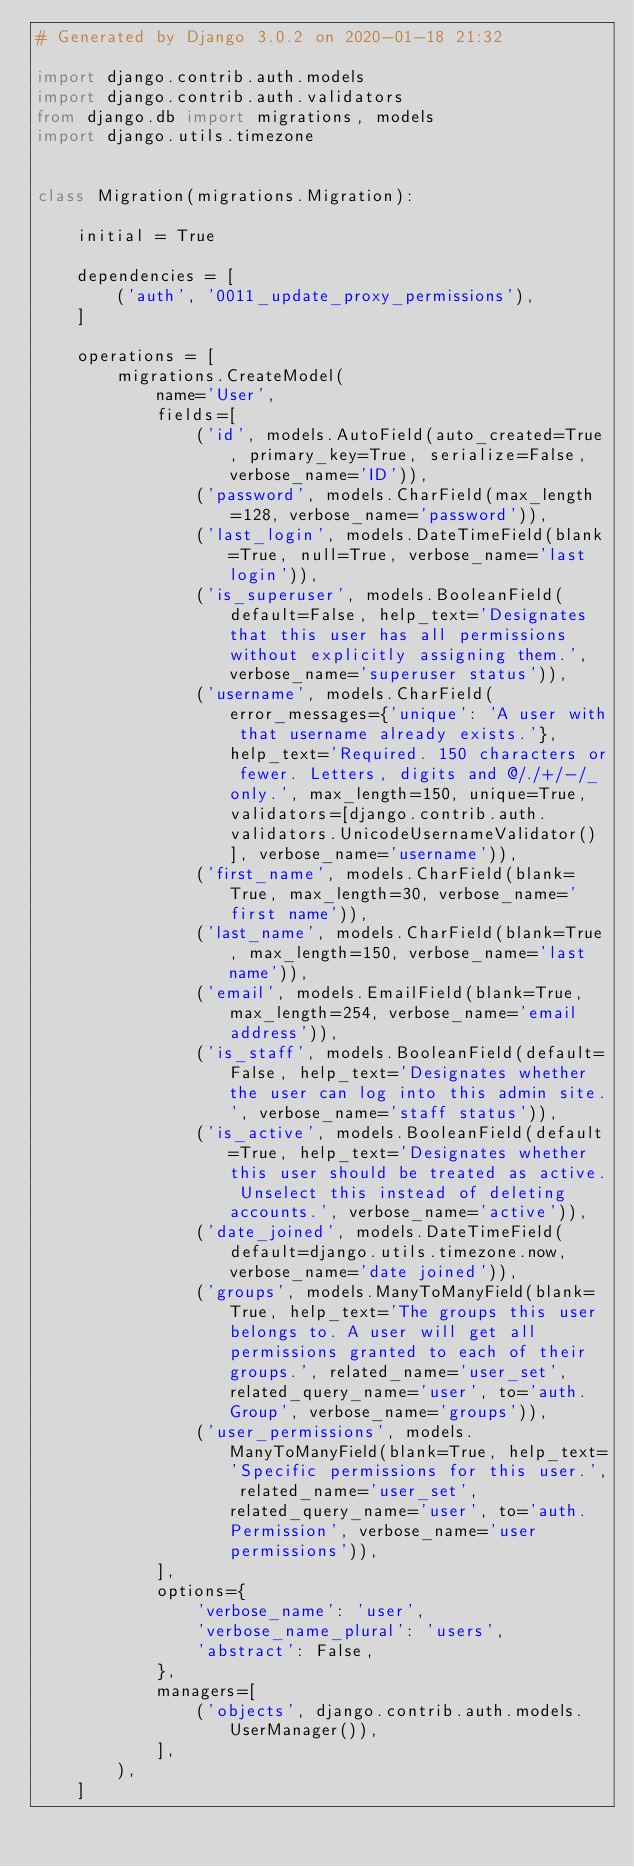<code> <loc_0><loc_0><loc_500><loc_500><_Python_># Generated by Django 3.0.2 on 2020-01-18 21:32

import django.contrib.auth.models
import django.contrib.auth.validators
from django.db import migrations, models
import django.utils.timezone


class Migration(migrations.Migration):

    initial = True

    dependencies = [
        ('auth', '0011_update_proxy_permissions'),
    ]

    operations = [
        migrations.CreateModel(
            name='User',
            fields=[
                ('id', models.AutoField(auto_created=True, primary_key=True, serialize=False, verbose_name='ID')),
                ('password', models.CharField(max_length=128, verbose_name='password')),
                ('last_login', models.DateTimeField(blank=True, null=True, verbose_name='last login')),
                ('is_superuser', models.BooleanField(default=False, help_text='Designates that this user has all permissions without explicitly assigning them.', verbose_name='superuser status')),
                ('username', models.CharField(error_messages={'unique': 'A user with that username already exists.'}, help_text='Required. 150 characters or fewer. Letters, digits and @/./+/-/_ only.', max_length=150, unique=True, validators=[django.contrib.auth.validators.UnicodeUsernameValidator()], verbose_name='username')),
                ('first_name', models.CharField(blank=True, max_length=30, verbose_name='first name')),
                ('last_name', models.CharField(blank=True, max_length=150, verbose_name='last name')),
                ('email', models.EmailField(blank=True, max_length=254, verbose_name='email address')),
                ('is_staff', models.BooleanField(default=False, help_text='Designates whether the user can log into this admin site.', verbose_name='staff status')),
                ('is_active', models.BooleanField(default=True, help_text='Designates whether this user should be treated as active. Unselect this instead of deleting accounts.', verbose_name='active')),
                ('date_joined', models.DateTimeField(default=django.utils.timezone.now, verbose_name='date joined')),
                ('groups', models.ManyToManyField(blank=True, help_text='The groups this user belongs to. A user will get all permissions granted to each of their groups.', related_name='user_set', related_query_name='user', to='auth.Group', verbose_name='groups')),
                ('user_permissions', models.ManyToManyField(blank=True, help_text='Specific permissions for this user.', related_name='user_set', related_query_name='user', to='auth.Permission', verbose_name='user permissions')),
            ],
            options={
                'verbose_name': 'user',
                'verbose_name_plural': 'users',
                'abstract': False,
            },
            managers=[
                ('objects', django.contrib.auth.models.UserManager()),
            ],
        ),
    ]
</code> 